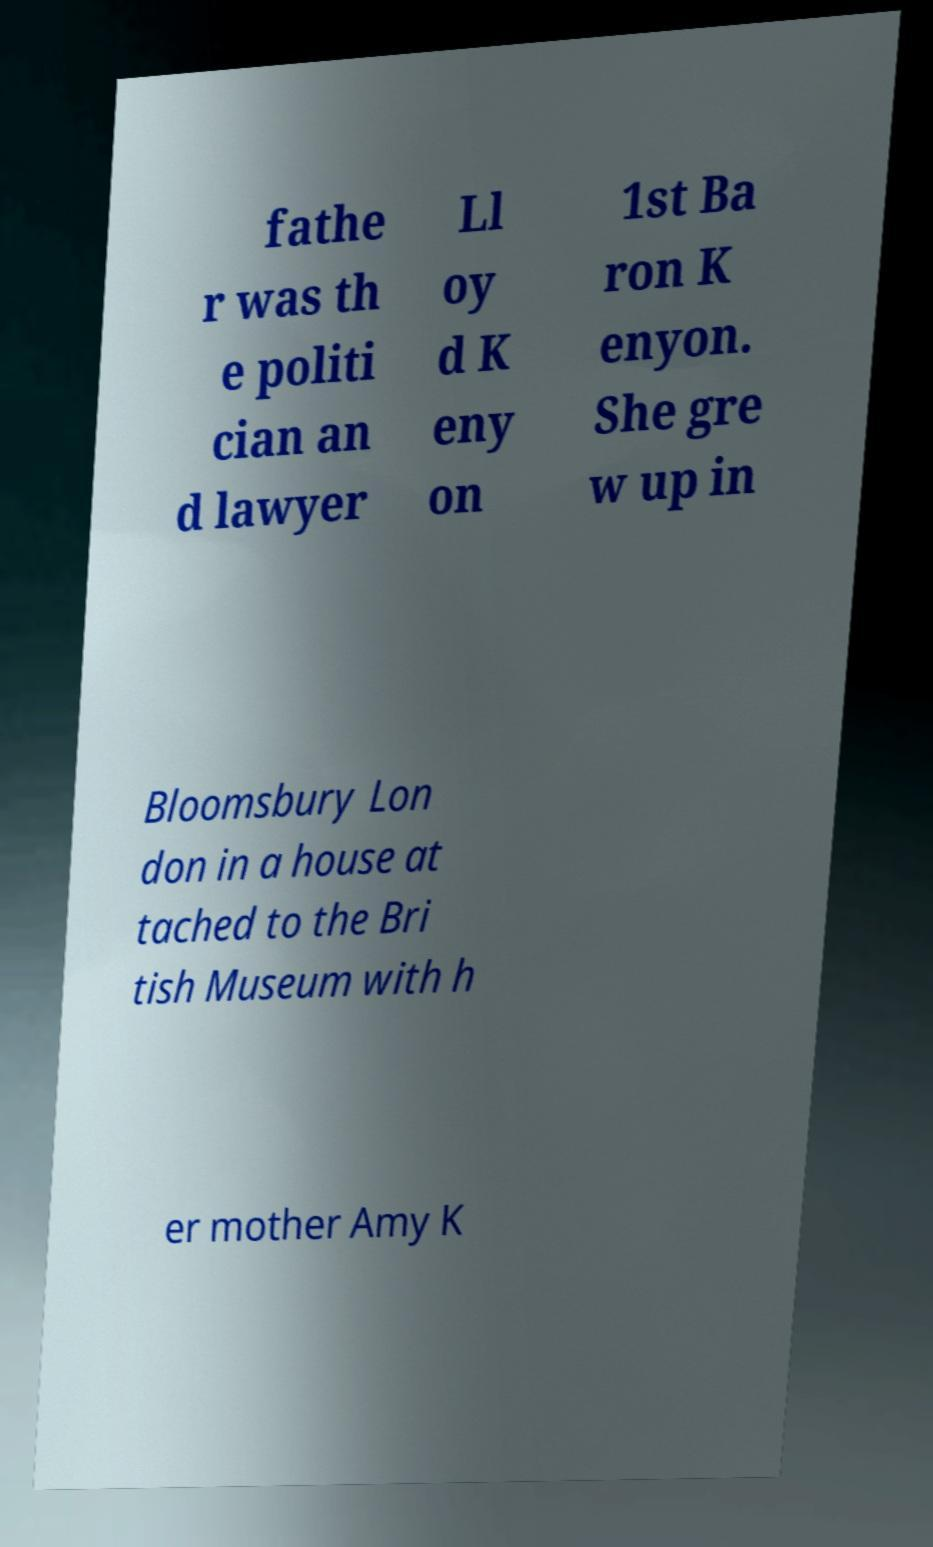Please read and relay the text visible in this image. What does it say? fathe r was th e politi cian an d lawyer Ll oy d K eny on 1st Ba ron K enyon. She gre w up in Bloomsbury Lon don in a house at tached to the Bri tish Museum with h er mother Amy K 